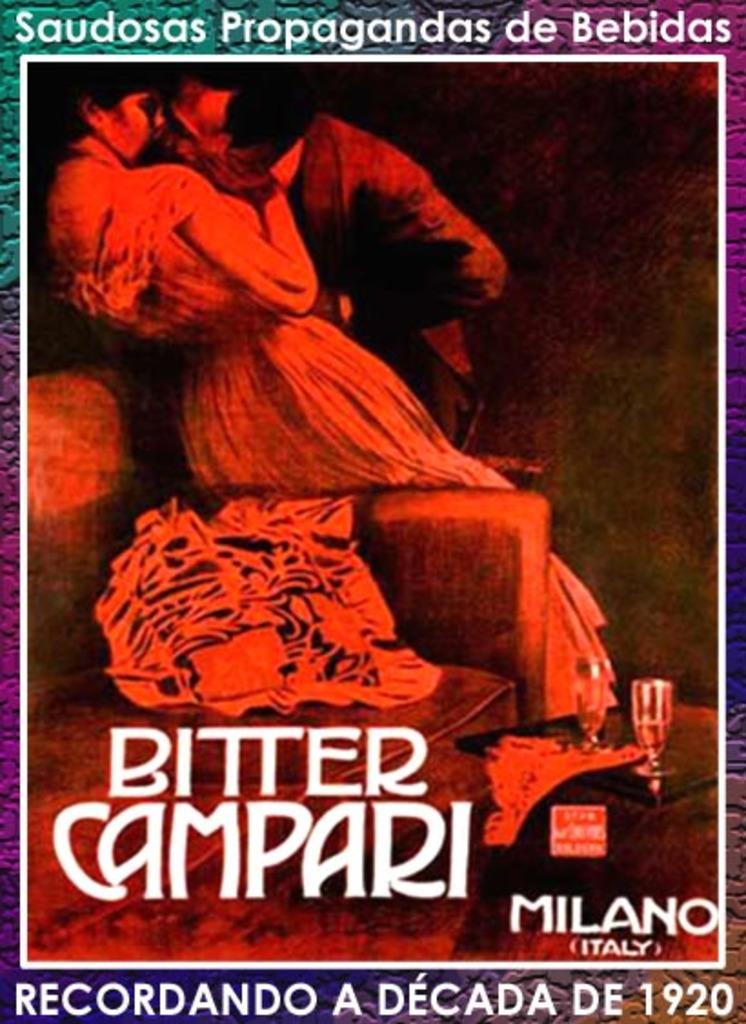What type of source material is the image from? The image appears to be from a book. How many people are present in the image? There is a man and a woman in the image. What objects can be seen on the table in the image? There are wine glasses on a table in the image. What color is the text that is written in the image? The name written in the image is in white color. What type of cake is being served in the image? There is no cake present in the image; it features a man, a woman, wine glasses, and text. 